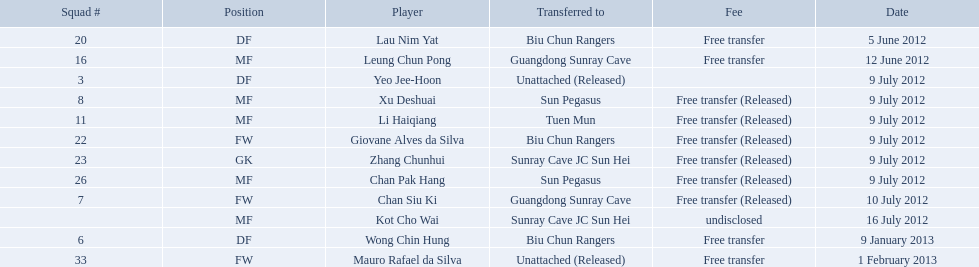Which sportsmen are included? Lau Nim Yat, Leung Chun Pong, Yeo Jee-Hoon, Xu Deshuai, Li Haiqiang, Giovane Alves da Silva, Zhang Chunhui, Chan Pak Hang, Chan Siu Ki, Kot Cho Wai, Wong Chin Hung, Mauro Rafael da Silva. When were the players added to the biu chun rangers roster? 5 June 2012, 9 July 2012, 9 January 2013. From those, what's the transfer date for wong chin hung? 9 January 2013. Which days had non-released free transfers occur? 5 June 2012, 12 June 2012, 9 January 2013, 1 February 2013. On those dates, when were the players moved to a different team? 5 June 2012, 12 June 2012, 9 January 2013. When were the transfers made to biu chun rangers? 5 June 2012, 9 January 2013. On which of these days did they get a df? 9 January 2013. On which dates did non-released free transfers take place? 5 June 2012, 12 June 2012, 9 January 2013, 1 February 2013. When did the players transfer to another team on these dates? 5 June 2012, 12 June 2012, 9 January 2013. When did the transfers to biu chun rangers happen? 5 June 2012, 9 January 2013. On which of these particular dates was a df received? 9 January 2013. 